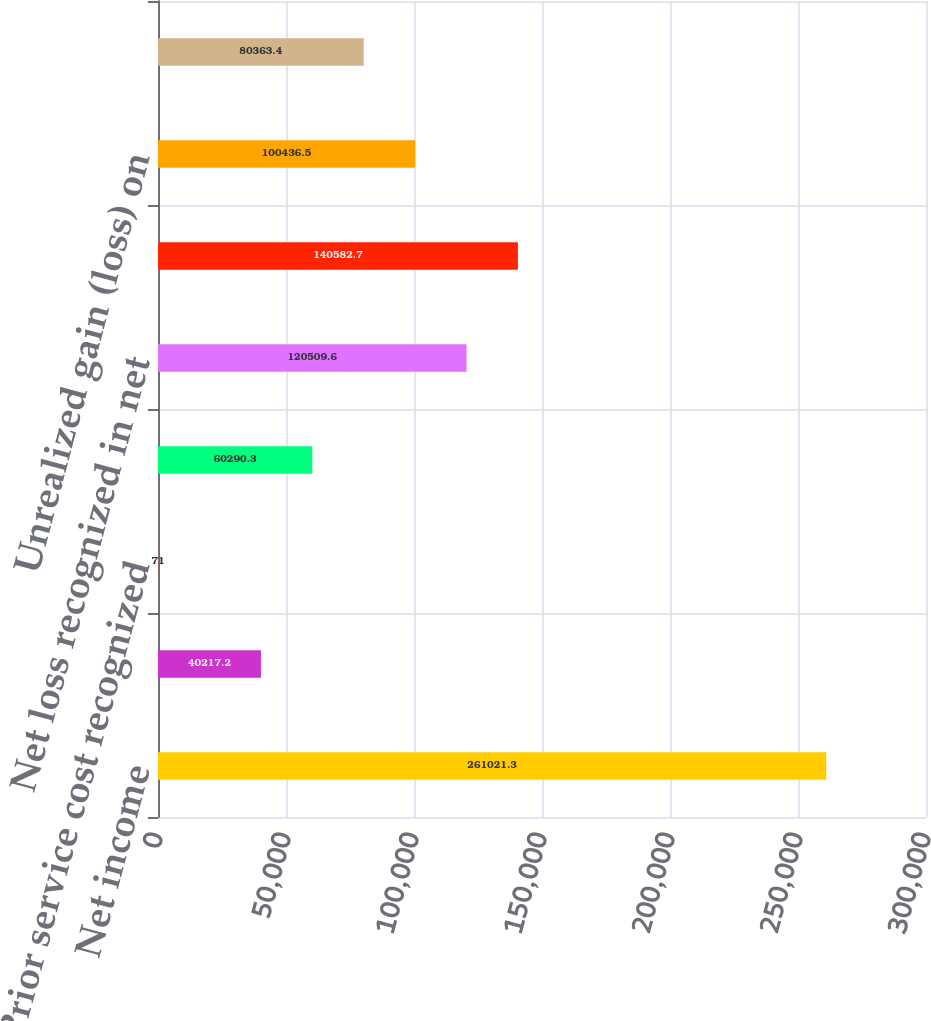<chart> <loc_0><loc_0><loc_500><loc_500><bar_chart><fcel>Net income<fcel>Foreign currency translation<fcel>Prior service cost recognized<fcel>Unamortized (loss) gain<fcel>Net loss recognized in net<fcel>Pension and other<fcel>Unrealized gain (loss) on<fcel>Reclassification adjustment on<nl><fcel>261021<fcel>40217.2<fcel>71<fcel>60290.3<fcel>120510<fcel>140583<fcel>100436<fcel>80363.4<nl></chart> 